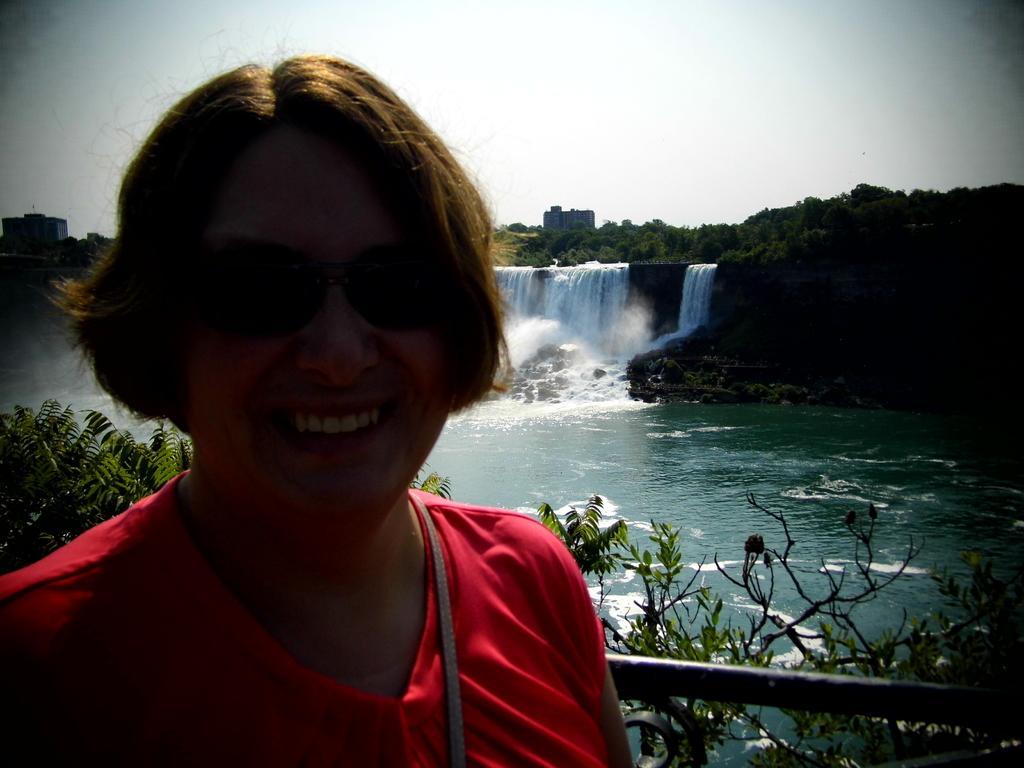Please provide a concise description of this image. In this image we can see a woman wearing glasses and also a red t shirt and smiling. In the background we can see the waterfalls, building, and also many trees. Sky is also visible. There is also a fence at the bottom. 